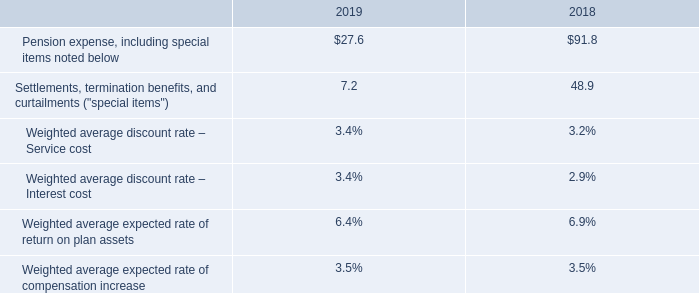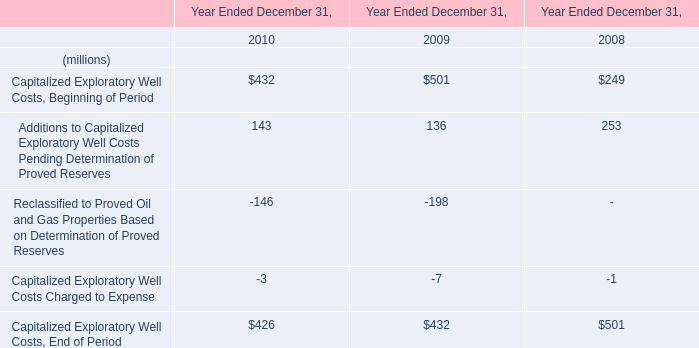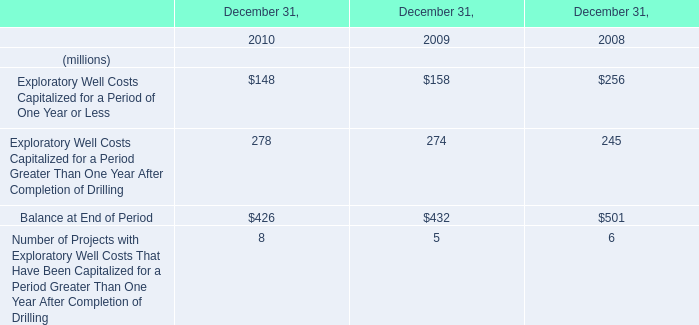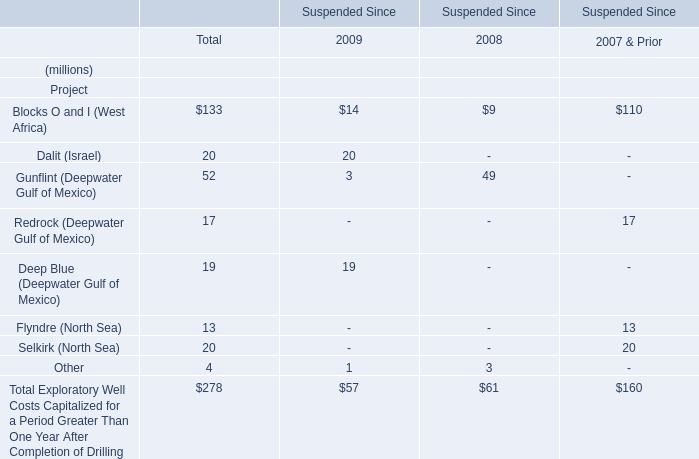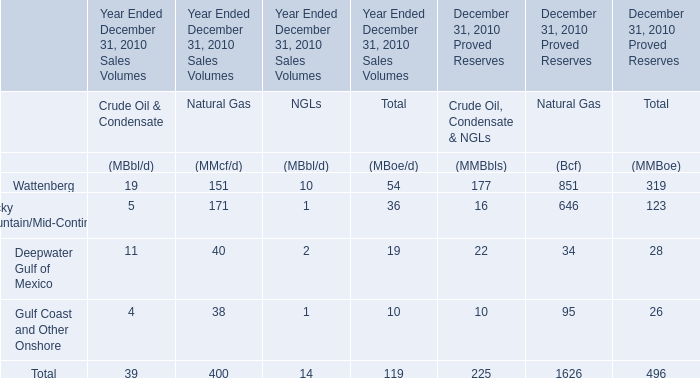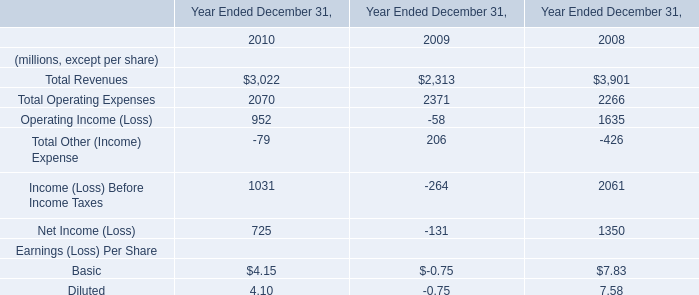What is the sum of the Gunflint (Deepwater Gulf of Mexico) and Deep Blue (Deepwater Gulf of Mexico) in the years where Dalit (Is is greater than 0? (in million) 
Computations: (3 + 19)
Answer: 22.0. 